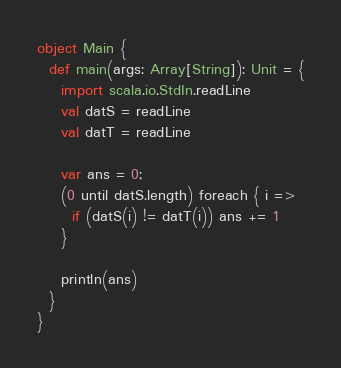<code> <loc_0><loc_0><loc_500><loc_500><_Scala_>object Main {
  def main(args: Array[String]): Unit = {
    import scala.io.StdIn.readLine
    val datS = readLine
    val datT = readLine

    var ans = 0;
    (0 until datS.length) foreach { i =>
      if (datS(i) != datT(i)) ans += 1
    }

    println(ans)
  }
}
</code> 